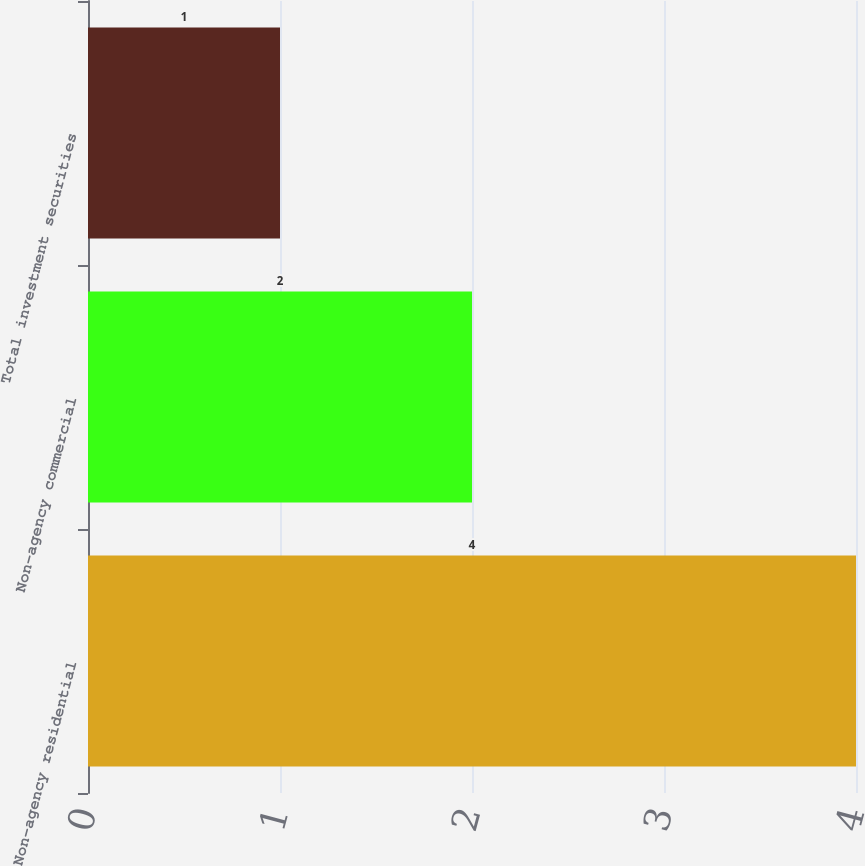Convert chart to OTSL. <chart><loc_0><loc_0><loc_500><loc_500><bar_chart><fcel>Non-agency residential<fcel>Non-agency commercial<fcel>Total investment securities<nl><fcel>4<fcel>2<fcel>1<nl></chart> 